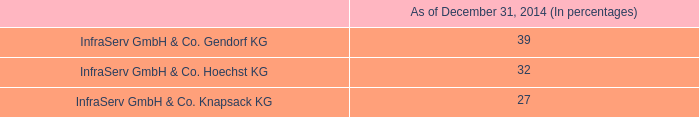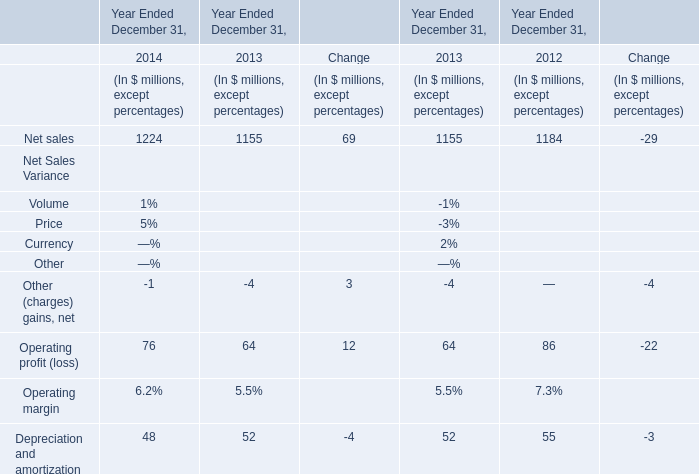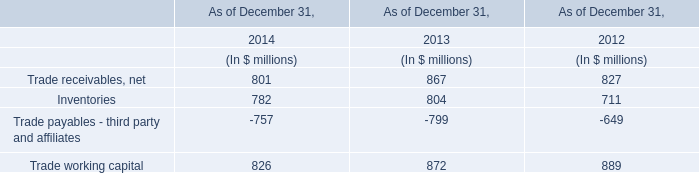What is the sum of the Net sales in the years where Operating profit (loss) is greater than 80? (in million) 
Answer: 1184. 